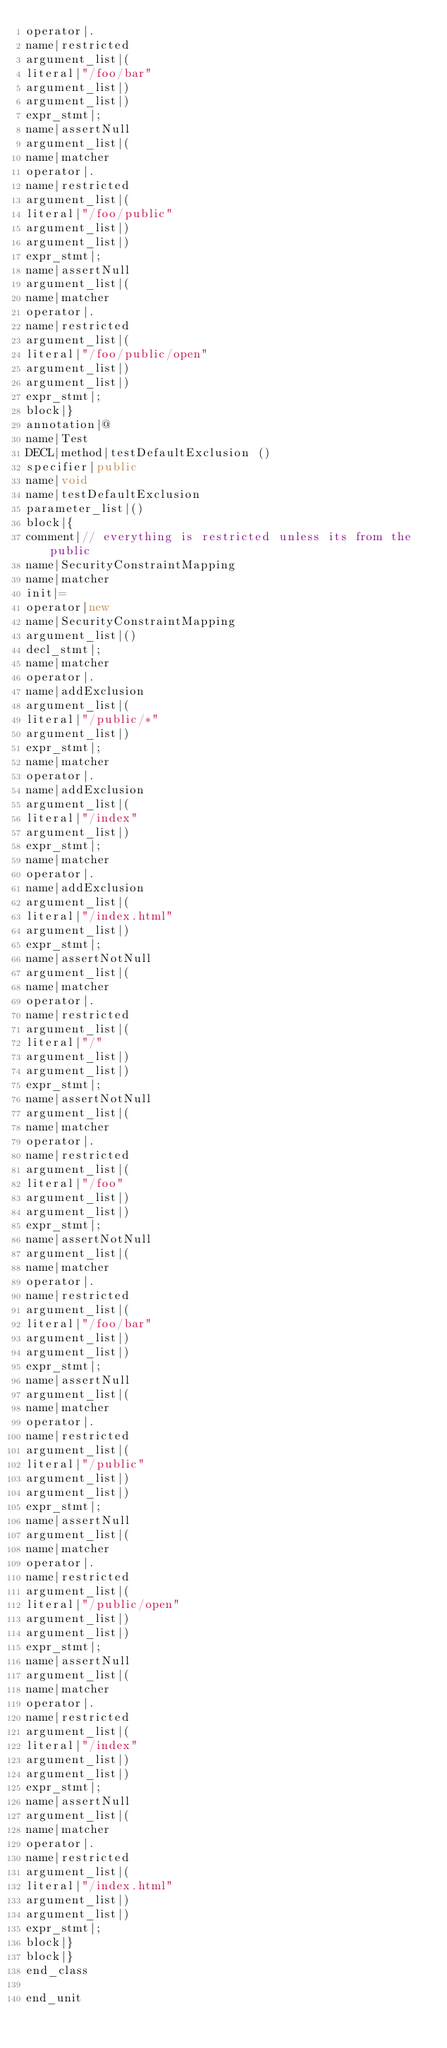<code> <loc_0><loc_0><loc_500><loc_500><_Java_>operator|.
name|restricted
argument_list|(
literal|"/foo/bar"
argument_list|)
argument_list|)
expr_stmt|;
name|assertNull
argument_list|(
name|matcher
operator|.
name|restricted
argument_list|(
literal|"/foo/public"
argument_list|)
argument_list|)
expr_stmt|;
name|assertNull
argument_list|(
name|matcher
operator|.
name|restricted
argument_list|(
literal|"/foo/public/open"
argument_list|)
argument_list|)
expr_stmt|;
block|}
annotation|@
name|Test
DECL|method|testDefaultExclusion ()
specifier|public
name|void
name|testDefaultExclusion
parameter_list|()
block|{
comment|// everything is restricted unless its from the public
name|SecurityConstraintMapping
name|matcher
init|=
operator|new
name|SecurityConstraintMapping
argument_list|()
decl_stmt|;
name|matcher
operator|.
name|addExclusion
argument_list|(
literal|"/public/*"
argument_list|)
expr_stmt|;
name|matcher
operator|.
name|addExclusion
argument_list|(
literal|"/index"
argument_list|)
expr_stmt|;
name|matcher
operator|.
name|addExclusion
argument_list|(
literal|"/index.html"
argument_list|)
expr_stmt|;
name|assertNotNull
argument_list|(
name|matcher
operator|.
name|restricted
argument_list|(
literal|"/"
argument_list|)
argument_list|)
expr_stmt|;
name|assertNotNull
argument_list|(
name|matcher
operator|.
name|restricted
argument_list|(
literal|"/foo"
argument_list|)
argument_list|)
expr_stmt|;
name|assertNotNull
argument_list|(
name|matcher
operator|.
name|restricted
argument_list|(
literal|"/foo/bar"
argument_list|)
argument_list|)
expr_stmt|;
name|assertNull
argument_list|(
name|matcher
operator|.
name|restricted
argument_list|(
literal|"/public"
argument_list|)
argument_list|)
expr_stmt|;
name|assertNull
argument_list|(
name|matcher
operator|.
name|restricted
argument_list|(
literal|"/public/open"
argument_list|)
argument_list|)
expr_stmt|;
name|assertNull
argument_list|(
name|matcher
operator|.
name|restricted
argument_list|(
literal|"/index"
argument_list|)
argument_list|)
expr_stmt|;
name|assertNull
argument_list|(
name|matcher
operator|.
name|restricted
argument_list|(
literal|"/index.html"
argument_list|)
argument_list|)
expr_stmt|;
block|}
block|}
end_class

end_unit

</code> 